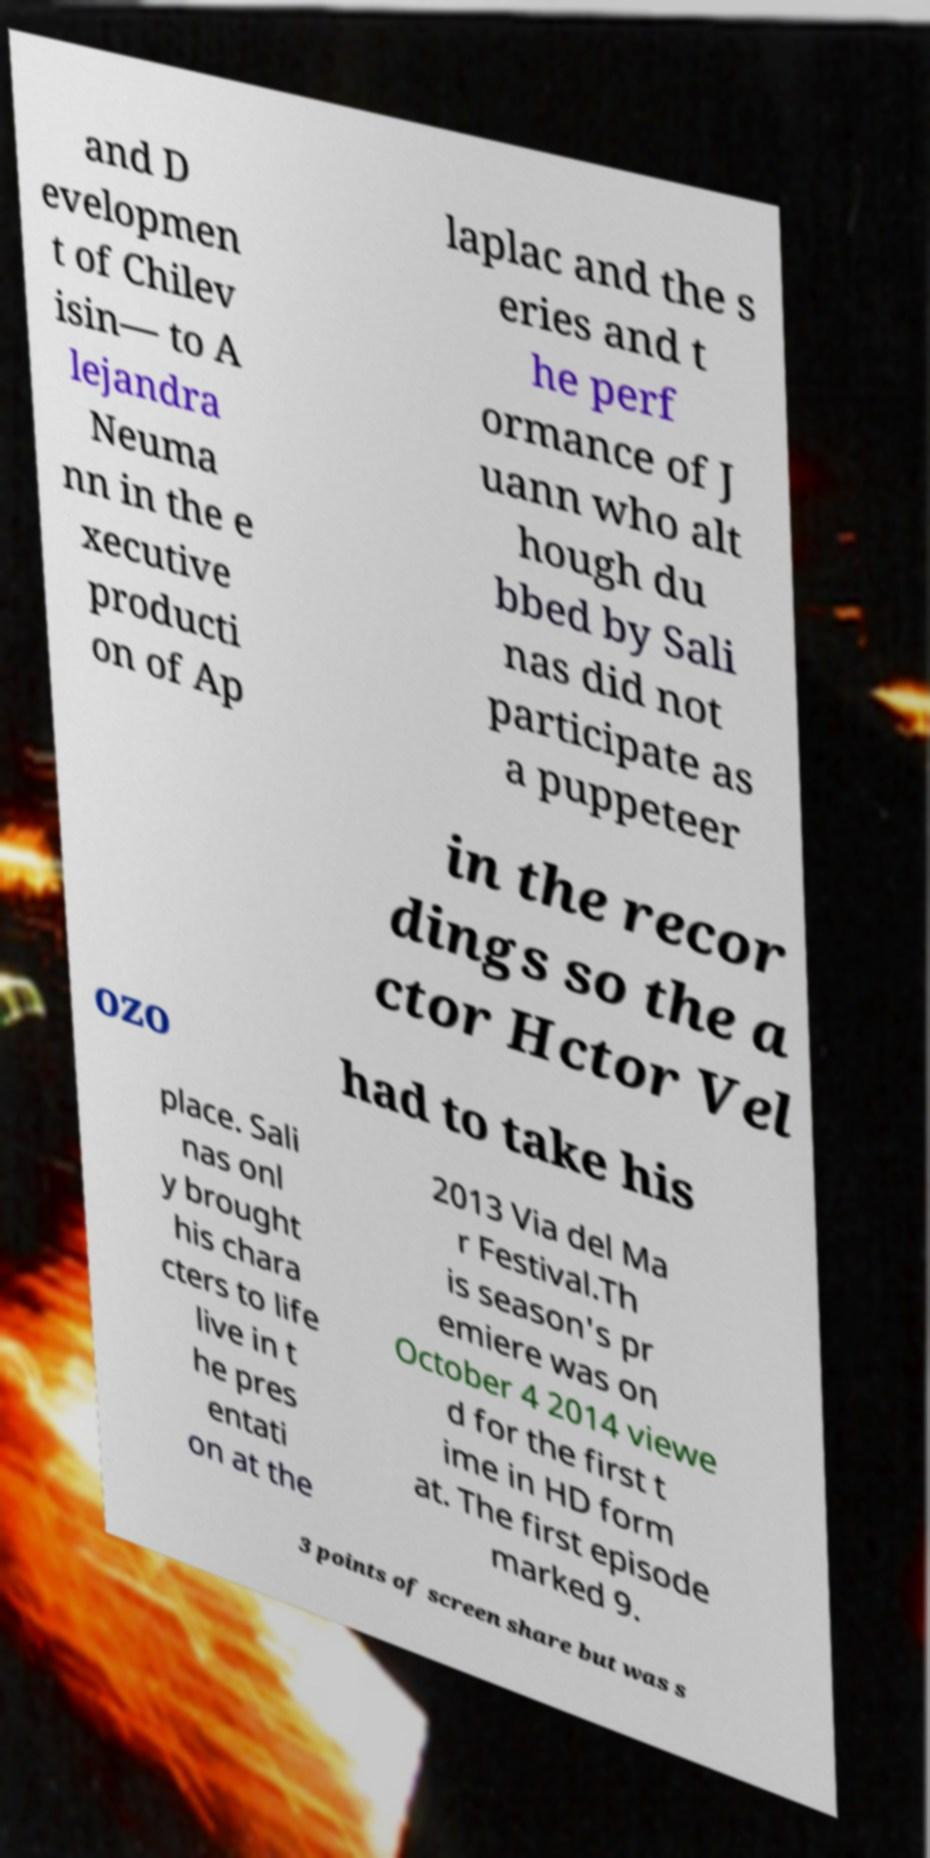Can you accurately transcribe the text from the provided image for me? and D evelopmen t of Chilev isin— to A lejandra Neuma nn in the e xecutive producti on of Ap laplac and the s eries and t he perf ormance of J uann who alt hough du bbed by Sali nas did not participate as a puppeteer in the recor dings so the a ctor Hctor Vel ozo had to take his place. Sali nas onl y brought his chara cters to life live in t he pres entati on at the 2013 Via del Ma r Festival.Th is season's pr emiere was on October 4 2014 viewe d for the first t ime in HD form at. The first episode marked 9. 3 points of screen share but was s 